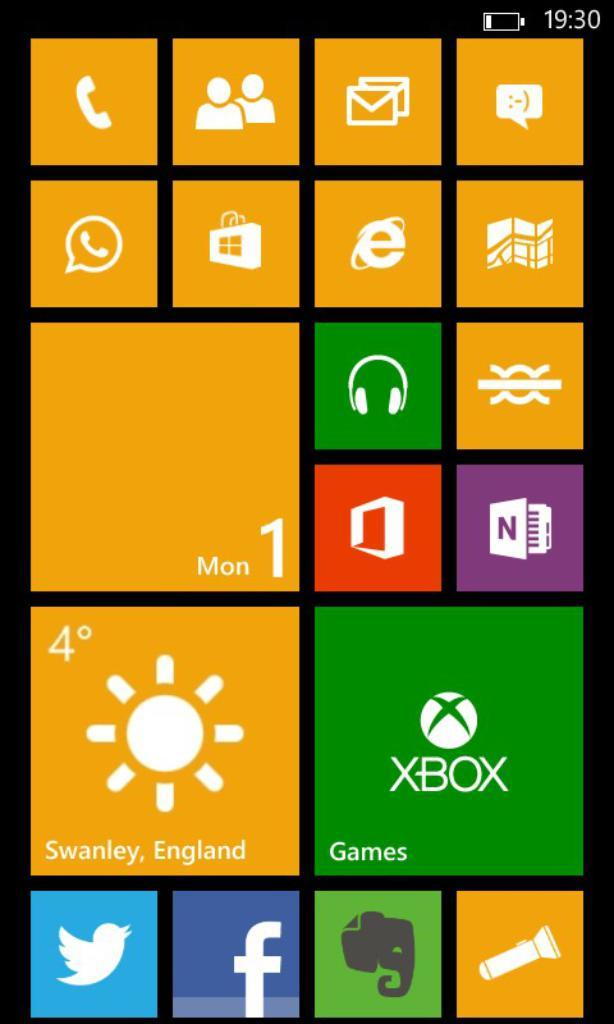<image>
Summarize the visual content of the image. The screen here shows that is is 4 degres in Swanley, England. 